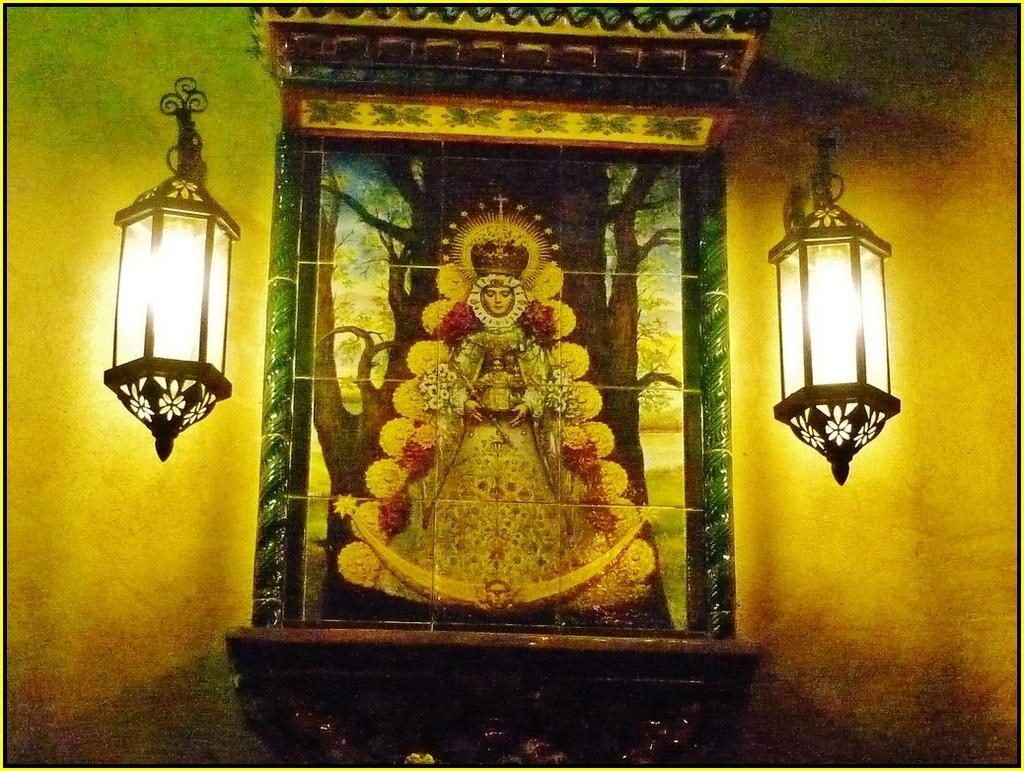What religious objects are present in the image? There are idols in the image. What type of building can be seen in the image? There is a temple in the image. What type of vegetation is visible in the image? There are trees in the image. What is visible in the sky in the image? The sky is visible in the image. How many lamps are present in the image? There are two lamps in the image. What can be inferred about the background of the image? The background of the image is multicolored. What type of object is the image contained within? The image appears to be a photo frame. What type of linen is draped over the idols in the image? There is no linen draped over the idols in the image; the idols are not covered. How does the cough of the person in the image affect the temple? There is no person coughing in the image, and therefore no effect on the temple can be observed. 